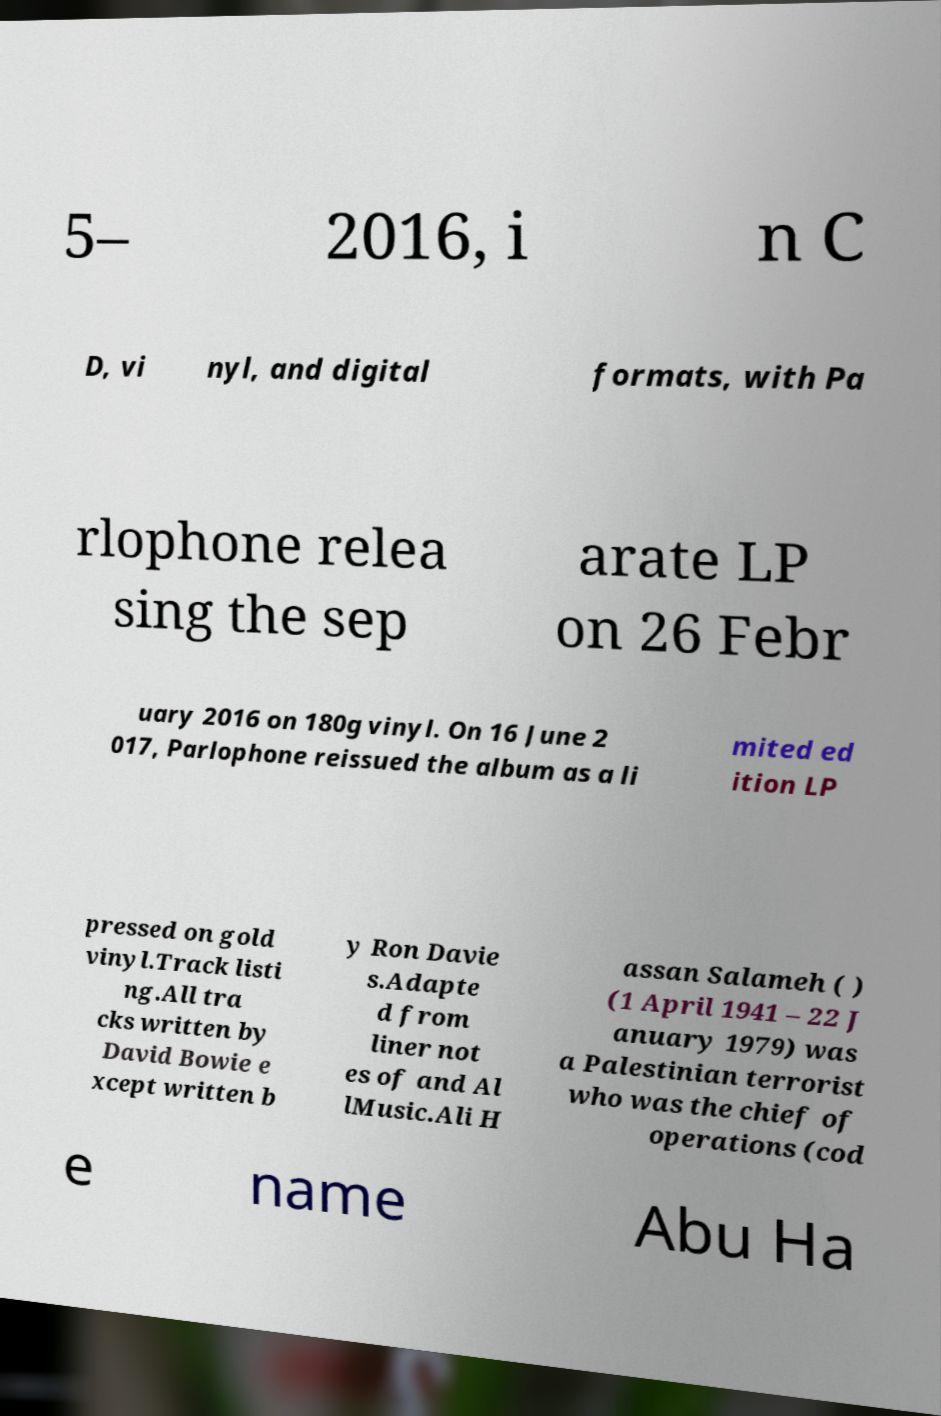Please read and relay the text visible in this image. What does it say? 5– 2016, i n C D, vi nyl, and digital formats, with Pa rlophone relea sing the sep arate LP on 26 Febr uary 2016 on 180g vinyl. On 16 June 2 017, Parlophone reissued the album as a li mited ed ition LP pressed on gold vinyl.Track listi ng.All tra cks written by David Bowie e xcept written b y Ron Davie s.Adapte d from liner not es of and Al lMusic.Ali H assan Salameh ( ) (1 April 1941 – 22 J anuary 1979) was a Palestinian terrorist who was the chief of operations (cod e name Abu Ha 